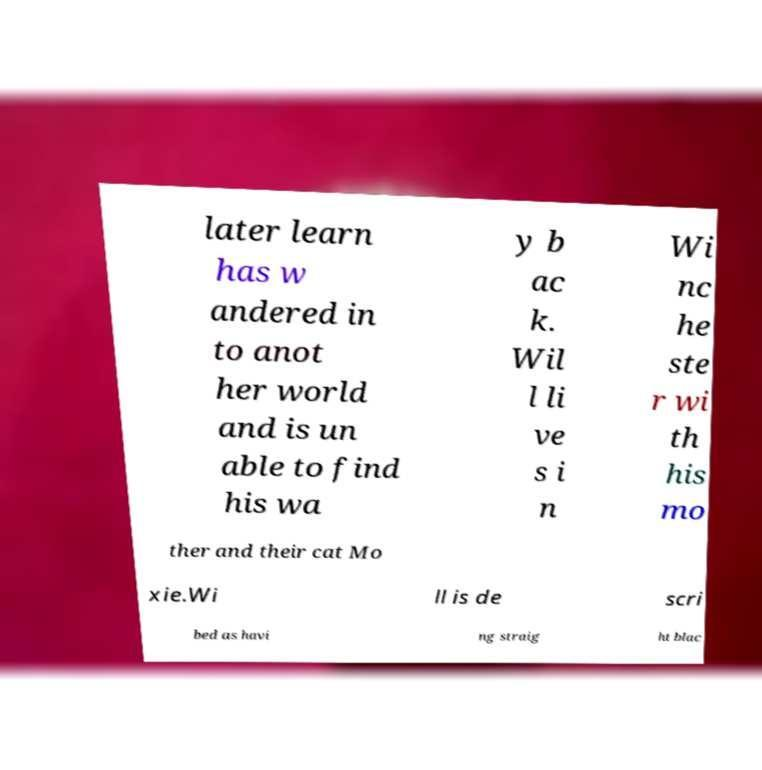For documentation purposes, I need the text within this image transcribed. Could you provide that? later learn has w andered in to anot her world and is un able to find his wa y b ac k. Wil l li ve s i n Wi nc he ste r wi th his mo ther and their cat Mo xie.Wi ll is de scri bed as havi ng straig ht blac 